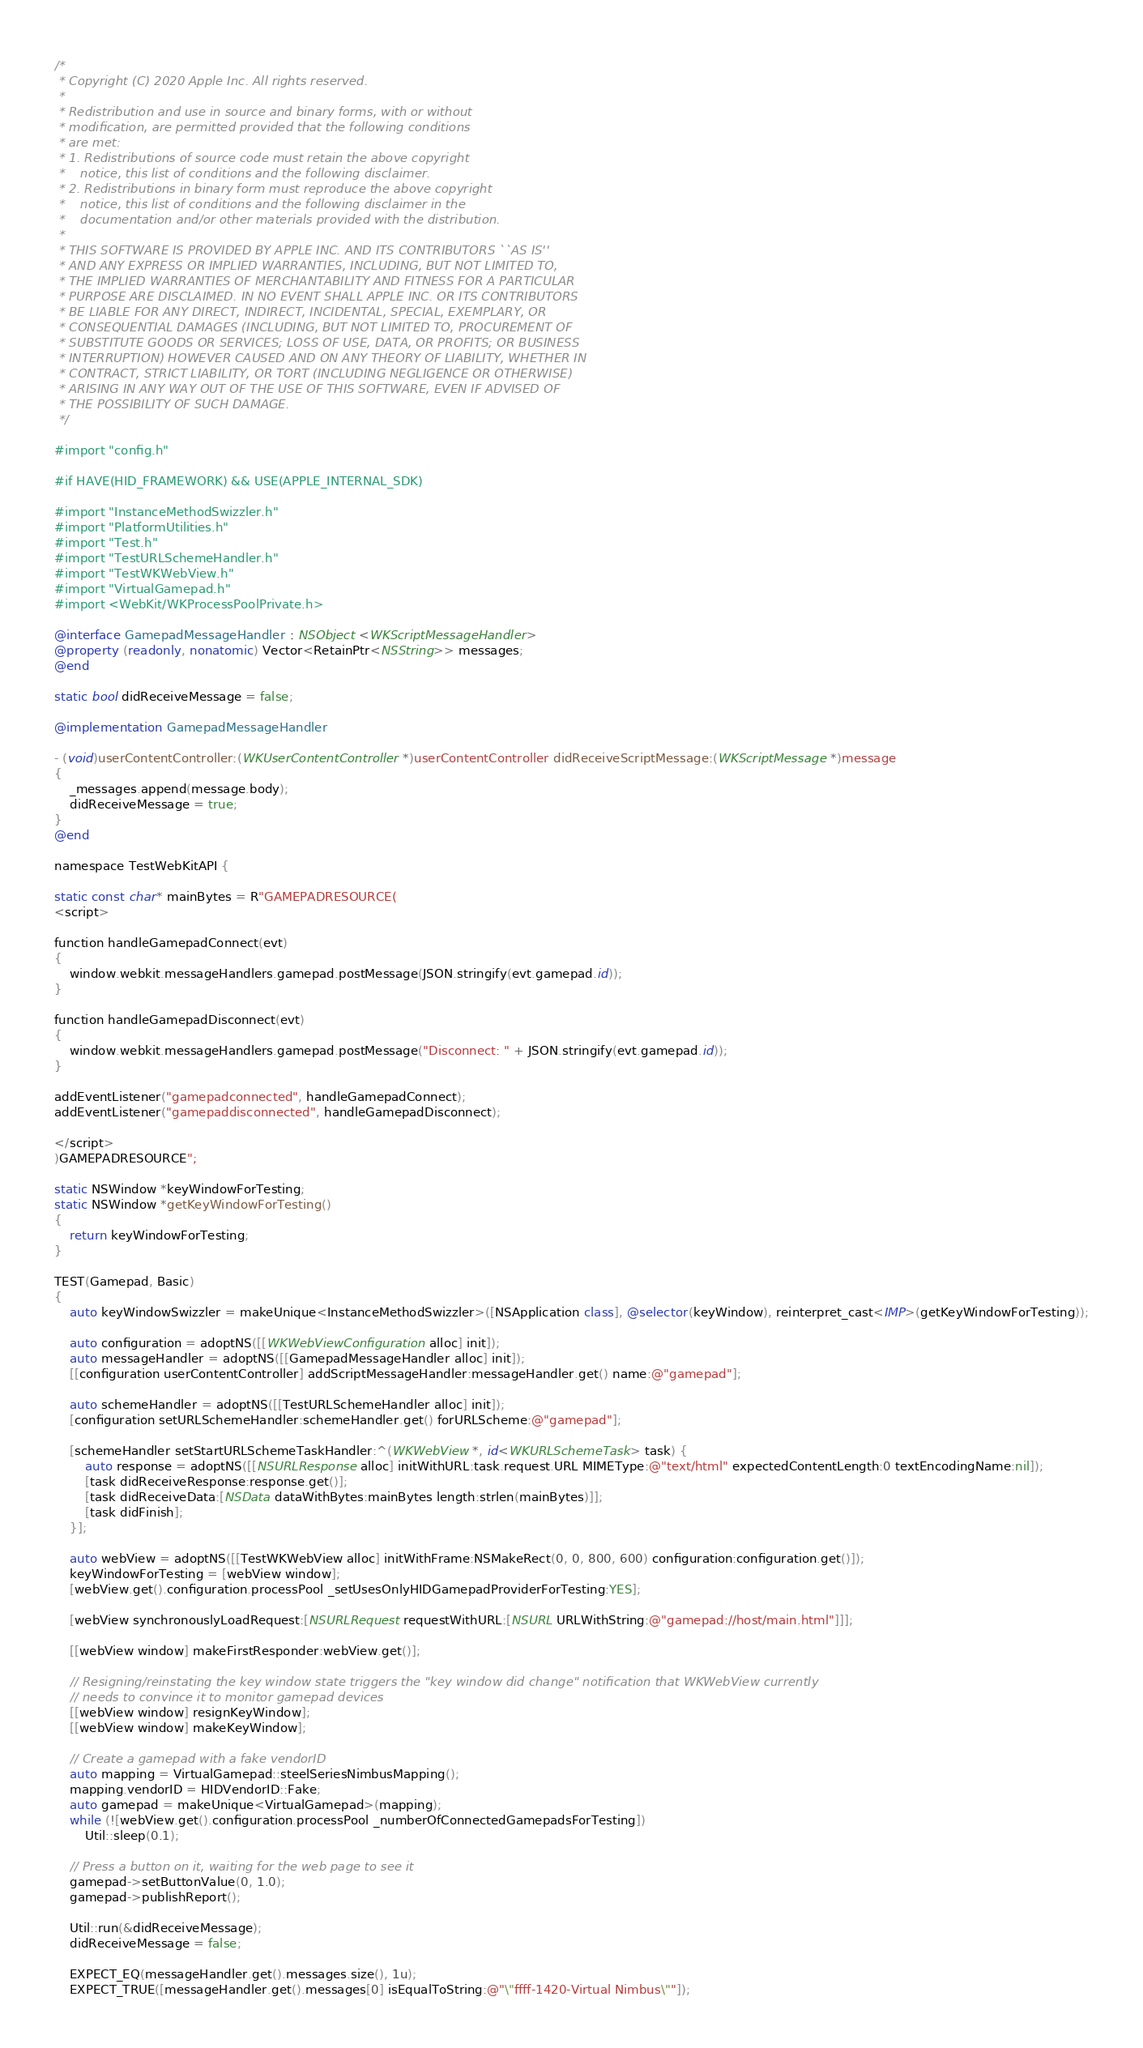<code> <loc_0><loc_0><loc_500><loc_500><_ObjectiveC_>/*
 * Copyright (C) 2020 Apple Inc. All rights reserved.
 *
 * Redistribution and use in source and binary forms, with or without
 * modification, are permitted provided that the following conditions
 * are met:
 * 1. Redistributions of source code must retain the above copyright
 *    notice, this list of conditions and the following disclaimer.
 * 2. Redistributions in binary form must reproduce the above copyright
 *    notice, this list of conditions and the following disclaimer in the
 *    documentation and/or other materials provided with the distribution.
 *
 * THIS SOFTWARE IS PROVIDED BY APPLE INC. AND ITS CONTRIBUTORS ``AS IS''
 * AND ANY EXPRESS OR IMPLIED WARRANTIES, INCLUDING, BUT NOT LIMITED TO,
 * THE IMPLIED WARRANTIES OF MERCHANTABILITY AND FITNESS FOR A PARTICULAR
 * PURPOSE ARE DISCLAIMED. IN NO EVENT SHALL APPLE INC. OR ITS CONTRIBUTORS
 * BE LIABLE FOR ANY DIRECT, INDIRECT, INCIDENTAL, SPECIAL, EXEMPLARY, OR
 * CONSEQUENTIAL DAMAGES (INCLUDING, BUT NOT LIMITED TO, PROCUREMENT OF
 * SUBSTITUTE GOODS OR SERVICES; LOSS OF USE, DATA, OR PROFITS; OR BUSINESS
 * INTERRUPTION) HOWEVER CAUSED AND ON ANY THEORY OF LIABILITY, WHETHER IN
 * CONTRACT, STRICT LIABILITY, OR TORT (INCLUDING NEGLIGENCE OR OTHERWISE)
 * ARISING IN ANY WAY OUT OF THE USE OF THIS SOFTWARE, EVEN IF ADVISED OF
 * THE POSSIBILITY OF SUCH DAMAGE.
 */

#import "config.h"

#if HAVE(HID_FRAMEWORK) && USE(APPLE_INTERNAL_SDK)

#import "InstanceMethodSwizzler.h"
#import "PlatformUtilities.h"
#import "Test.h"
#import "TestURLSchemeHandler.h"
#import "TestWKWebView.h"
#import "VirtualGamepad.h"
#import <WebKit/WKProcessPoolPrivate.h>

@interface GamepadMessageHandler : NSObject <WKScriptMessageHandler>
@property (readonly, nonatomic) Vector<RetainPtr<NSString>> messages;
@end

static bool didReceiveMessage = false;

@implementation GamepadMessageHandler

- (void)userContentController:(WKUserContentController *)userContentController didReceiveScriptMessage:(WKScriptMessage *)message
{
    _messages.append(message.body);
    didReceiveMessage = true;
}
@end

namespace TestWebKitAPI {

static const char* mainBytes = R"GAMEPADRESOURCE(
<script>

function handleGamepadConnect(evt)
{
    window.webkit.messageHandlers.gamepad.postMessage(JSON.stringify(evt.gamepad.id));
}

function handleGamepadDisconnect(evt)
{
    window.webkit.messageHandlers.gamepad.postMessage("Disconnect: " + JSON.stringify(evt.gamepad.id));
}

addEventListener("gamepadconnected", handleGamepadConnect);
addEventListener("gamepaddisconnected", handleGamepadDisconnect);

</script>
)GAMEPADRESOURCE";

static NSWindow *keyWindowForTesting;
static NSWindow *getKeyWindowForTesting()
{
    return keyWindowForTesting;
}

TEST(Gamepad, Basic)
{
    auto keyWindowSwizzler = makeUnique<InstanceMethodSwizzler>([NSApplication class], @selector(keyWindow), reinterpret_cast<IMP>(getKeyWindowForTesting));

    auto configuration = adoptNS([[WKWebViewConfiguration alloc] init]);
    auto messageHandler = adoptNS([[GamepadMessageHandler alloc] init]);
    [[configuration userContentController] addScriptMessageHandler:messageHandler.get() name:@"gamepad"];

    auto schemeHandler = adoptNS([[TestURLSchemeHandler alloc] init]);
    [configuration setURLSchemeHandler:schemeHandler.get() forURLScheme:@"gamepad"];

    [schemeHandler setStartURLSchemeTaskHandler:^(WKWebView *, id<WKURLSchemeTask> task) {
        auto response = adoptNS([[NSURLResponse alloc] initWithURL:task.request.URL MIMEType:@"text/html" expectedContentLength:0 textEncodingName:nil]);
        [task didReceiveResponse:response.get()];
        [task didReceiveData:[NSData dataWithBytes:mainBytes length:strlen(mainBytes)]];
        [task didFinish];
    }];

    auto webView = adoptNS([[TestWKWebView alloc] initWithFrame:NSMakeRect(0, 0, 800, 600) configuration:configuration.get()]);
    keyWindowForTesting = [webView window];
    [webView.get().configuration.processPool _setUsesOnlyHIDGamepadProviderForTesting:YES];

    [webView synchronouslyLoadRequest:[NSURLRequest requestWithURL:[NSURL URLWithString:@"gamepad://host/main.html"]]];

    [[webView window] makeFirstResponder:webView.get()];

    // Resigning/reinstating the key window state triggers the "key window did change" notification that WKWebView currently
    // needs to convince it to monitor gamepad devices
    [[webView window] resignKeyWindow];
    [[webView window] makeKeyWindow];

    // Create a gamepad with a fake vendorID
    auto mapping = VirtualGamepad::steelSeriesNimbusMapping();
    mapping.vendorID = HIDVendorID::Fake;
    auto gamepad = makeUnique<VirtualGamepad>(mapping);
    while (![webView.get().configuration.processPool _numberOfConnectedGamepadsForTesting])
        Util::sleep(0.1);

    // Press a button on it, waiting for the web page to see it
    gamepad->setButtonValue(0, 1.0);
    gamepad->publishReport();

    Util::run(&didReceiveMessage);
    didReceiveMessage = false;

    EXPECT_EQ(messageHandler.get().messages.size(), 1u);
    EXPECT_TRUE([messageHandler.get().messages[0] isEqualToString:@"\"ffff-1420-Virtual Nimbus\""]);</code> 